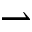<formula> <loc_0><loc_0><loc_500><loc_500>\rightharpoonup</formula> 